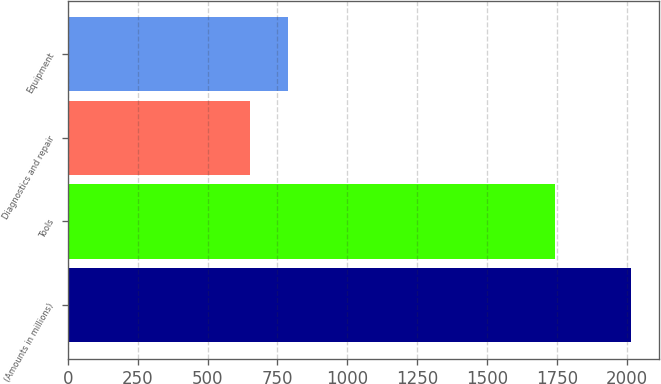<chart> <loc_0><loc_0><loc_500><loc_500><bar_chart><fcel>(Amounts in millions)<fcel>Tools<fcel>Diagnostics and repair<fcel>Equipment<nl><fcel>2013<fcel>1743.3<fcel>652<fcel>788.1<nl></chart> 